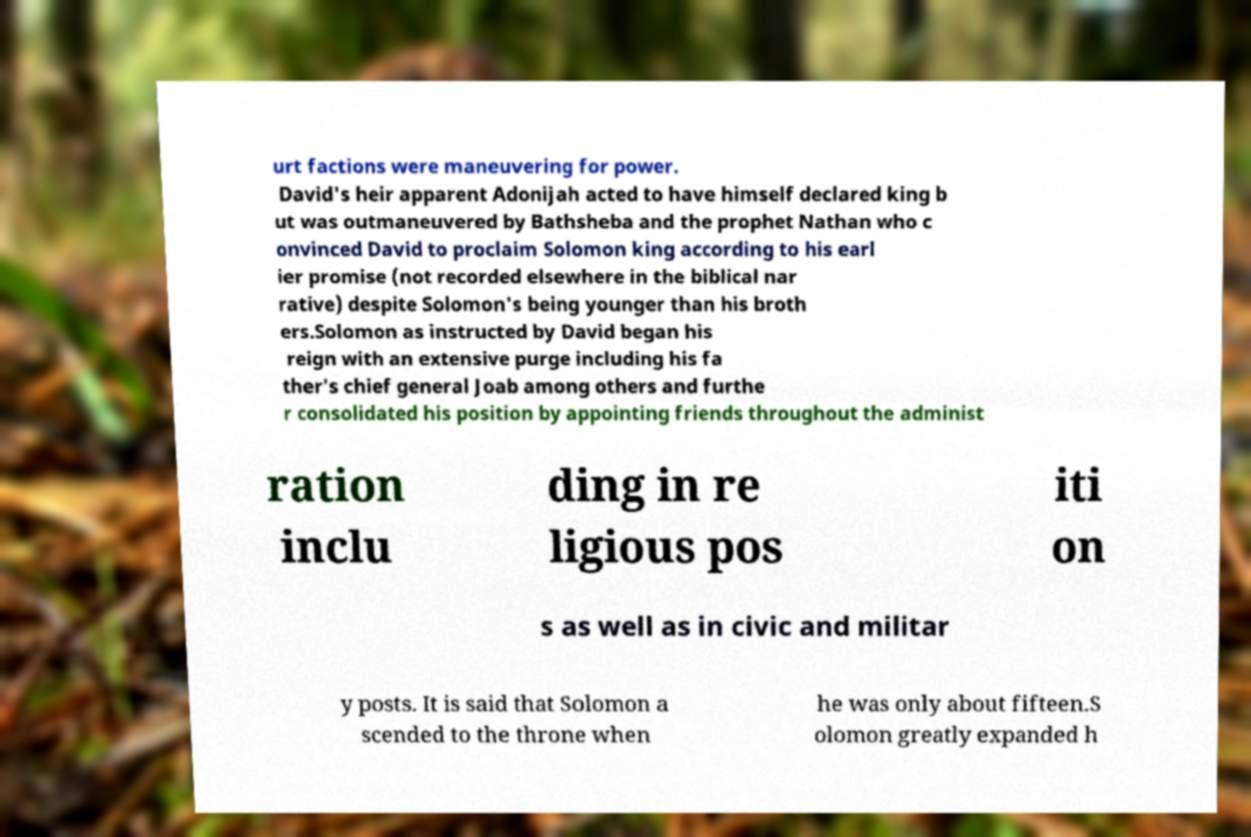Could you assist in decoding the text presented in this image and type it out clearly? urt factions were maneuvering for power. David's heir apparent Adonijah acted to have himself declared king b ut was outmaneuvered by Bathsheba and the prophet Nathan who c onvinced David to proclaim Solomon king according to his earl ier promise (not recorded elsewhere in the biblical nar rative) despite Solomon's being younger than his broth ers.Solomon as instructed by David began his reign with an extensive purge including his fa ther's chief general Joab among others and furthe r consolidated his position by appointing friends throughout the administ ration inclu ding in re ligious pos iti on s as well as in civic and militar y posts. It is said that Solomon a scended to the throne when he was only about fifteen.S olomon greatly expanded h 